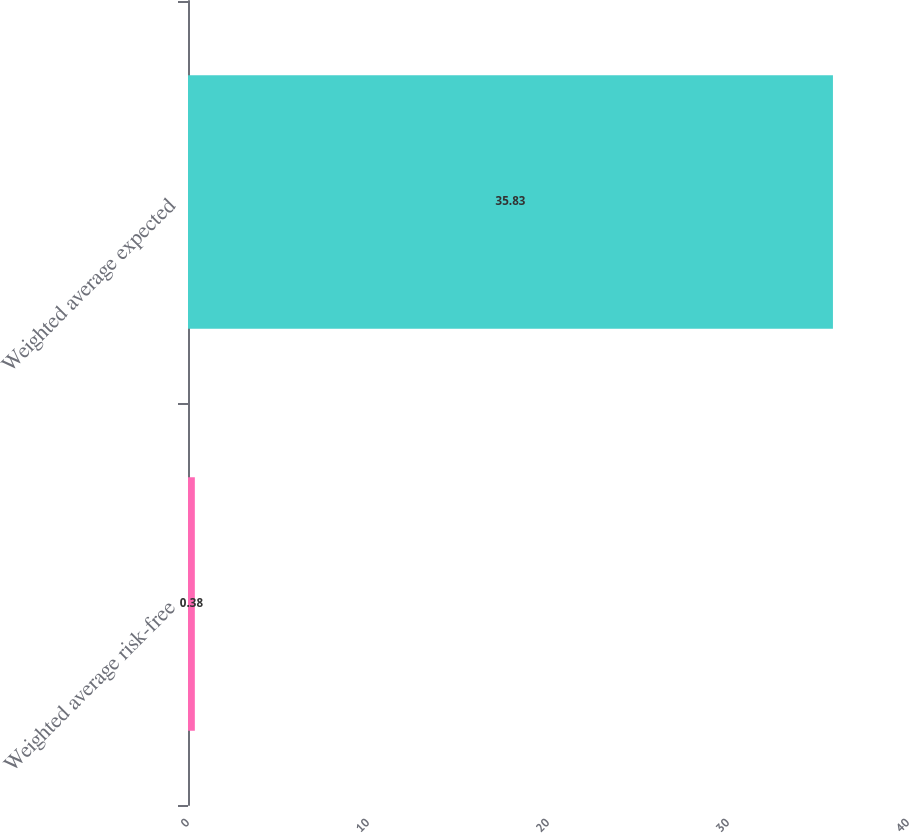Convert chart to OTSL. <chart><loc_0><loc_0><loc_500><loc_500><bar_chart><fcel>Weighted average risk-free<fcel>Weighted average expected<nl><fcel>0.38<fcel>35.83<nl></chart> 